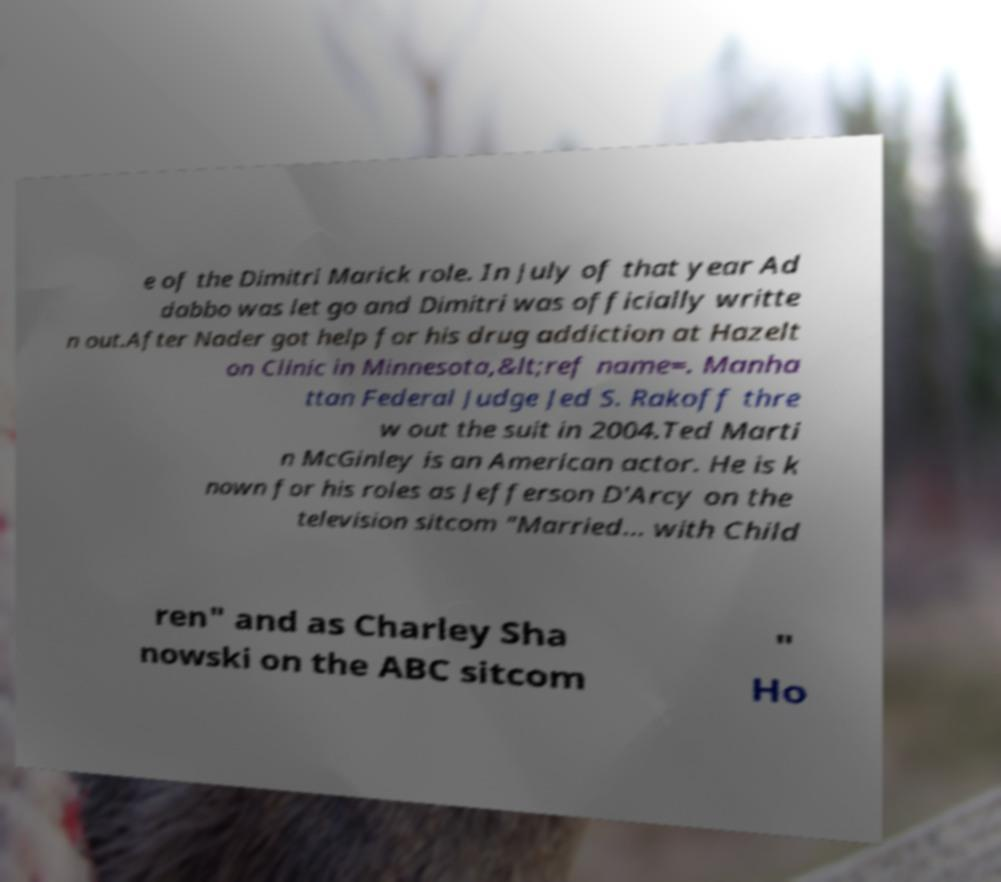Can you read and provide the text displayed in the image?This photo seems to have some interesting text. Can you extract and type it out for me? e of the Dimitri Marick role. In July of that year Ad dabbo was let go and Dimitri was officially writte n out.After Nader got help for his drug addiction at Hazelt on Clinic in Minnesota,&lt;ref name=. Manha ttan Federal Judge Jed S. Rakoff thre w out the suit in 2004.Ted Marti n McGinley is an American actor. He is k nown for his roles as Jefferson D'Arcy on the television sitcom "Married... with Child ren" and as Charley Sha nowski on the ABC sitcom " Ho 